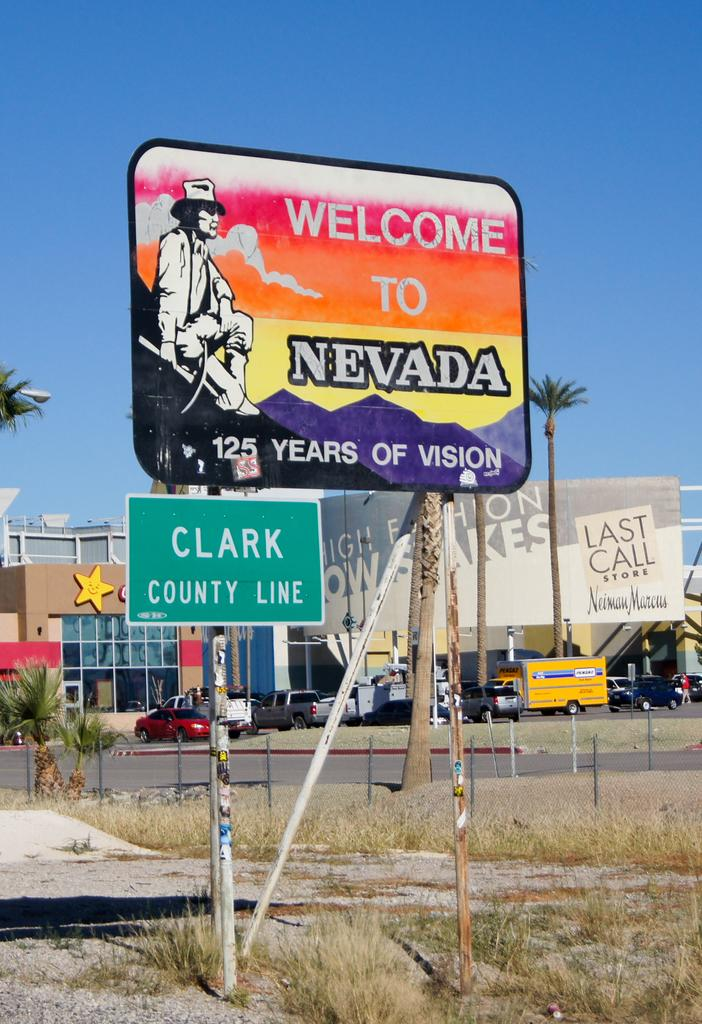<image>
Render a clear and concise summary of the photo. A welcome sign above a sign for the Clark county line 